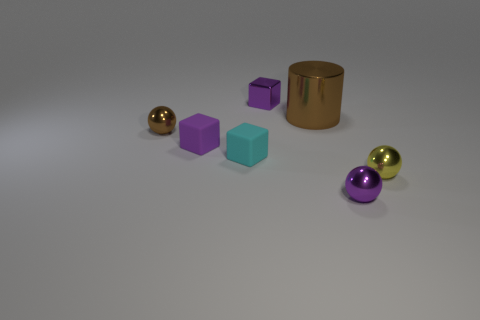Add 1 cyan rubber objects. How many objects exist? 8 Subtract all cylinders. How many objects are left? 6 Subtract all purple rubber blocks. Subtract all brown objects. How many objects are left? 4 Add 5 large brown things. How many large brown things are left? 6 Add 7 tiny cubes. How many tiny cubes exist? 10 Subtract 1 purple spheres. How many objects are left? 6 